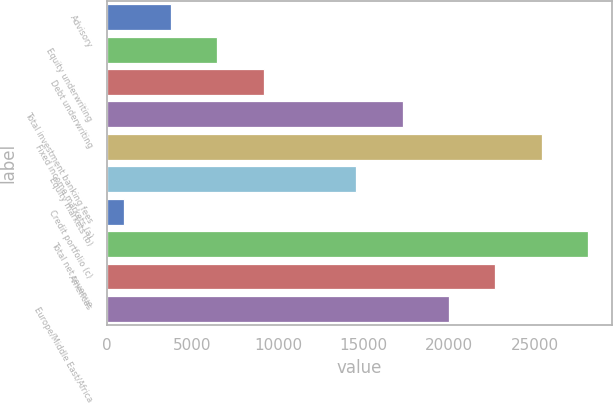Convert chart to OTSL. <chart><loc_0><loc_0><loc_500><loc_500><bar_chart><fcel>Advisory<fcel>Equity underwriting<fcel>Debt underwriting<fcel>Total investment banking fees<fcel>Fixed income markets (a)<fcel>Equity markets (b)<fcel>Credit portfolio (c)<fcel>Total net revenue<fcel>Americas<fcel>Europe/Middle East/Africa<nl><fcel>3726.2<fcel>6435.4<fcel>9144.6<fcel>17272.2<fcel>25399.8<fcel>14563<fcel>1017<fcel>28109<fcel>22690.6<fcel>19981.4<nl></chart> 